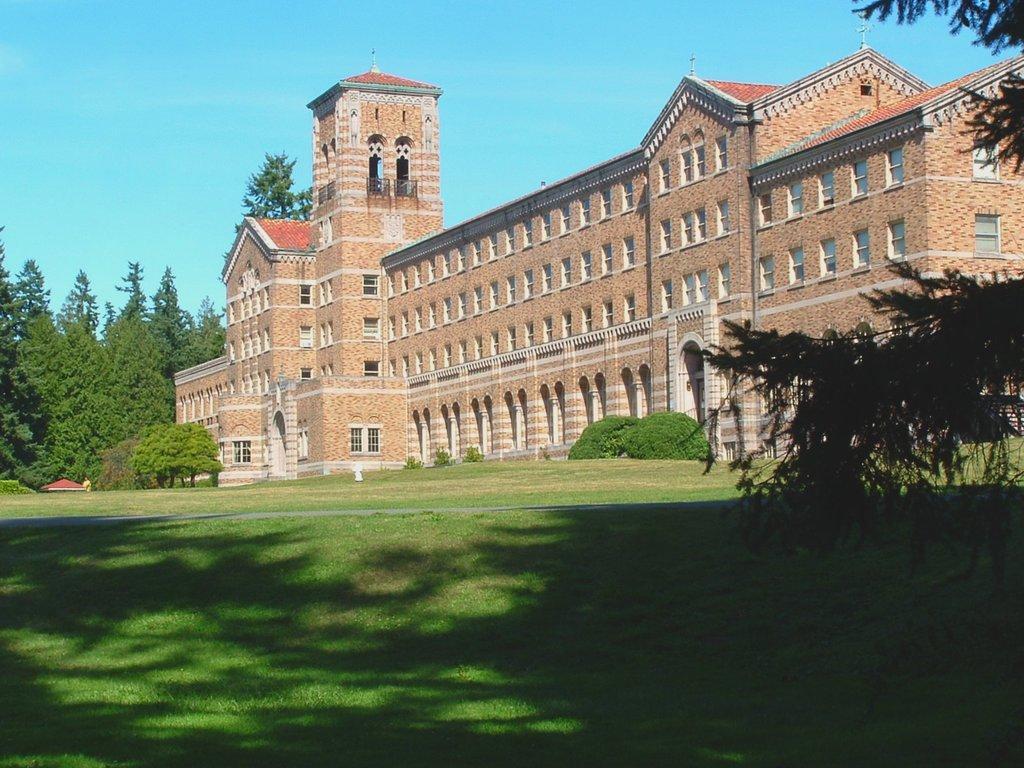Please provide a concise description of this image. In this image in the front there's grass on the ground. On the right side there are leaves. In the background there is a castle and there are trees. 